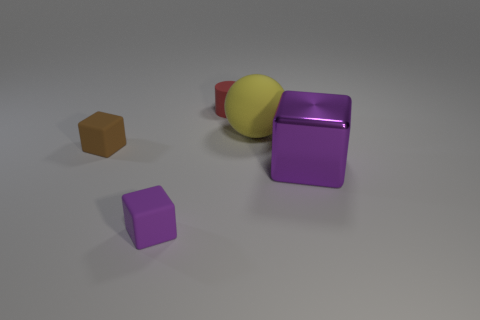Is there any other thing that has the same shape as the large matte thing?
Your answer should be compact. No. Is there any other thing that is the same material as the big cube?
Offer a terse response. No. What color is the block that is to the right of the small rubber cube that is in front of the big purple shiny thing?
Give a very brief answer. Purple. What number of gray things are matte things or small cylinders?
Offer a terse response. 0. There is a object that is left of the big yellow rubber thing and on the right side of the purple matte block; what is its color?
Your response must be concise. Red. How many large things are gray metal spheres or brown blocks?
Offer a terse response. 0. What size is the other purple thing that is the same shape as the tiny purple object?
Provide a succinct answer. Large. What shape is the big yellow rubber thing?
Keep it short and to the point. Sphere. Are the tiny purple block and the small thing that is behind the large ball made of the same material?
Give a very brief answer. Yes. What number of metallic things are yellow things or big red cylinders?
Your answer should be compact. 0. 